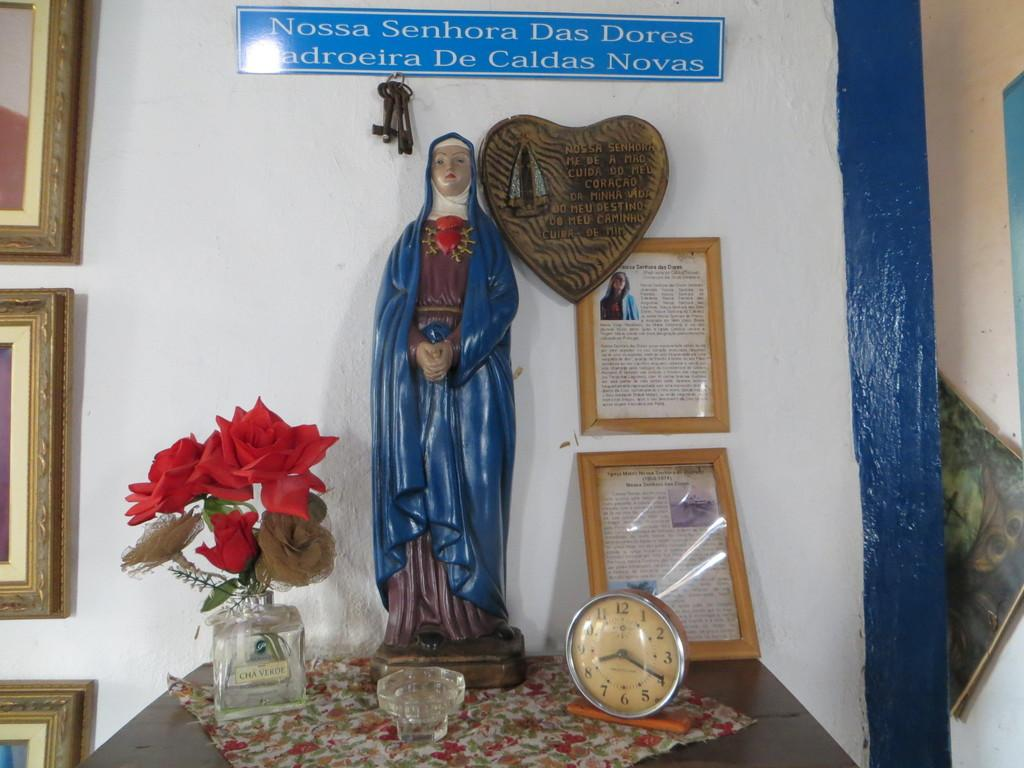<image>
Summarize the visual content of the image. A small shrine at a desk with a sign for Nossa Senhora Das Dores over a statuette. 